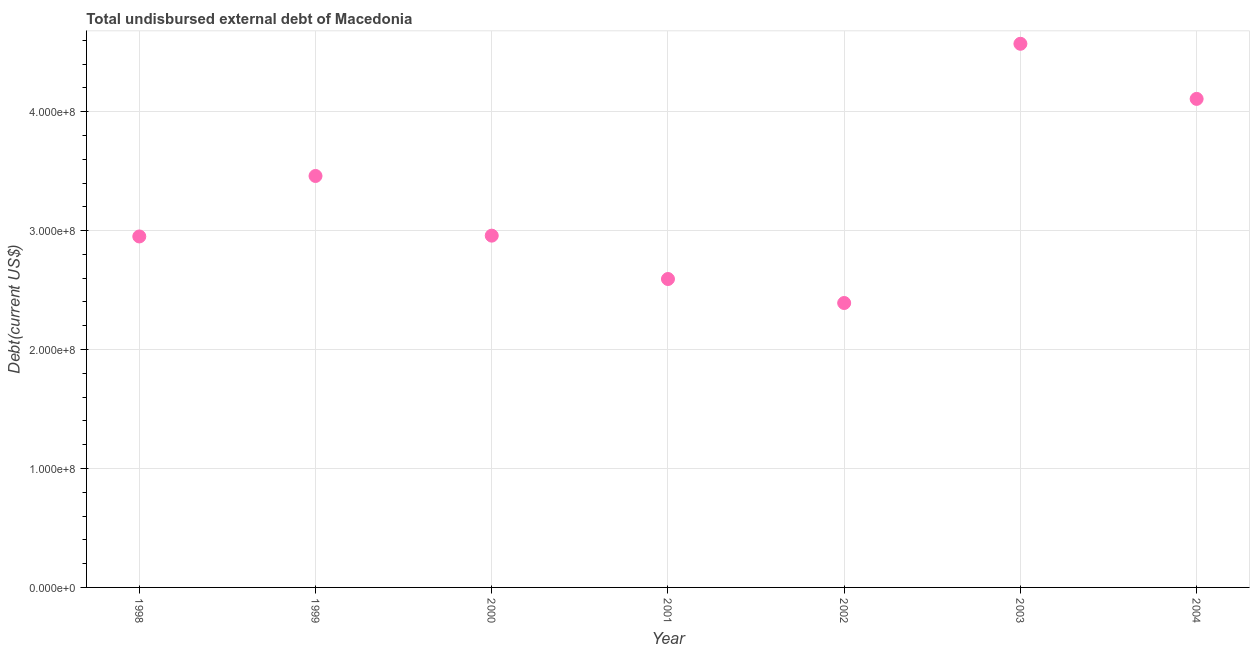What is the total debt in 2003?
Make the answer very short. 4.57e+08. Across all years, what is the maximum total debt?
Your answer should be compact. 4.57e+08. Across all years, what is the minimum total debt?
Give a very brief answer. 2.39e+08. What is the sum of the total debt?
Make the answer very short. 2.30e+09. What is the difference between the total debt in 2000 and 2004?
Make the answer very short. -1.15e+08. What is the average total debt per year?
Make the answer very short. 3.29e+08. What is the median total debt?
Your answer should be compact. 2.96e+08. In how many years, is the total debt greater than 420000000 US$?
Make the answer very short. 1. Do a majority of the years between 1998 and 2001 (inclusive) have total debt greater than 100000000 US$?
Provide a succinct answer. Yes. What is the ratio of the total debt in 2000 to that in 2002?
Keep it short and to the point. 1.24. What is the difference between the highest and the second highest total debt?
Provide a short and direct response. 4.63e+07. Is the sum of the total debt in 1998 and 1999 greater than the maximum total debt across all years?
Make the answer very short. Yes. What is the difference between the highest and the lowest total debt?
Ensure brevity in your answer.  2.18e+08. In how many years, is the total debt greater than the average total debt taken over all years?
Your answer should be compact. 3. Does the total debt monotonically increase over the years?
Keep it short and to the point. No. How many dotlines are there?
Provide a succinct answer. 1. How many years are there in the graph?
Offer a terse response. 7. What is the difference between two consecutive major ticks on the Y-axis?
Your response must be concise. 1.00e+08. Does the graph contain any zero values?
Your answer should be compact. No. What is the title of the graph?
Give a very brief answer. Total undisbursed external debt of Macedonia. What is the label or title of the Y-axis?
Make the answer very short. Debt(current US$). What is the Debt(current US$) in 1998?
Your answer should be very brief. 2.95e+08. What is the Debt(current US$) in 1999?
Your response must be concise. 3.46e+08. What is the Debt(current US$) in 2000?
Make the answer very short. 2.96e+08. What is the Debt(current US$) in 2001?
Your answer should be very brief. 2.59e+08. What is the Debt(current US$) in 2002?
Your answer should be very brief. 2.39e+08. What is the Debt(current US$) in 2003?
Offer a terse response. 4.57e+08. What is the Debt(current US$) in 2004?
Your answer should be very brief. 4.11e+08. What is the difference between the Debt(current US$) in 1998 and 1999?
Provide a short and direct response. -5.08e+07. What is the difference between the Debt(current US$) in 1998 and 2000?
Give a very brief answer. -6.78e+05. What is the difference between the Debt(current US$) in 1998 and 2001?
Provide a succinct answer. 3.58e+07. What is the difference between the Debt(current US$) in 1998 and 2002?
Offer a very short reply. 5.59e+07. What is the difference between the Debt(current US$) in 1998 and 2003?
Keep it short and to the point. -1.62e+08. What is the difference between the Debt(current US$) in 1998 and 2004?
Make the answer very short. -1.16e+08. What is the difference between the Debt(current US$) in 1999 and 2000?
Your answer should be very brief. 5.02e+07. What is the difference between the Debt(current US$) in 1999 and 2001?
Provide a short and direct response. 8.66e+07. What is the difference between the Debt(current US$) in 1999 and 2002?
Offer a very short reply. 1.07e+08. What is the difference between the Debt(current US$) in 1999 and 2003?
Your answer should be compact. -1.11e+08. What is the difference between the Debt(current US$) in 1999 and 2004?
Provide a short and direct response. -6.48e+07. What is the difference between the Debt(current US$) in 2000 and 2001?
Give a very brief answer. 3.65e+07. What is the difference between the Debt(current US$) in 2000 and 2002?
Provide a succinct answer. 5.66e+07. What is the difference between the Debt(current US$) in 2000 and 2003?
Ensure brevity in your answer.  -1.61e+08. What is the difference between the Debt(current US$) in 2000 and 2004?
Make the answer very short. -1.15e+08. What is the difference between the Debt(current US$) in 2001 and 2002?
Make the answer very short. 2.02e+07. What is the difference between the Debt(current US$) in 2001 and 2003?
Provide a succinct answer. -1.98e+08. What is the difference between the Debt(current US$) in 2001 and 2004?
Ensure brevity in your answer.  -1.51e+08. What is the difference between the Debt(current US$) in 2002 and 2003?
Ensure brevity in your answer.  -2.18e+08. What is the difference between the Debt(current US$) in 2002 and 2004?
Keep it short and to the point. -1.72e+08. What is the difference between the Debt(current US$) in 2003 and 2004?
Your answer should be compact. 4.63e+07. What is the ratio of the Debt(current US$) in 1998 to that in 1999?
Give a very brief answer. 0.85. What is the ratio of the Debt(current US$) in 1998 to that in 2000?
Your response must be concise. 1. What is the ratio of the Debt(current US$) in 1998 to that in 2001?
Make the answer very short. 1.14. What is the ratio of the Debt(current US$) in 1998 to that in 2002?
Your response must be concise. 1.23. What is the ratio of the Debt(current US$) in 1998 to that in 2003?
Make the answer very short. 0.65. What is the ratio of the Debt(current US$) in 1998 to that in 2004?
Offer a terse response. 0.72. What is the ratio of the Debt(current US$) in 1999 to that in 2000?
Your answer should be compact. 1.17. What is the ratio of the Debt(current US$) in 1999 to that in 2001?
Your response must be concise. 1.33. What is the ratio of the Debt(current US$) in 1999 to that in 2002?
Provide a succinct answer. 1.45. What is the ratio of the Debt(current US$) in 1999 to that in 2003?
Make the answer very short. 0.76. What is the ratio of the Debt(current US$) in 1999 to that in 2004?
Provide a short and direct response. 0.84. What is the ratio of the Debt(current US$) in 2000 to that in 2001?
Offer a very short reply. 1.14. What is the ratio of the Debt(current US$) in 2000 to that in 2002?
Provide a succinct answer. 1.24. What is the ratio of the Debt(current US$) in 2000 to that in 2003?
Provide a succinct answer. 0.65. What is the ratio of the Debt(current US$) in 2000 to that in 2004?
Offer a very short reply. 0.72. What is the ratio of the Debt(current US$) in 2001 to that in 2002?
Offer a terse response. 1.08. What is the ratio of the Debt(current US$) in 2001 to that in 2003?
Ensure brevity in your answer.  0.57. What is the ratio of the Debt(current US$) in 2001 to that in 2004?
Ensure brevity in your answer.  0.63. What is the ratio of the Debt(current US$) in 2002 to that in 2003?
Provide a short and direct response. 0.52. What is the ratio of the Debt(current US$) in 2002 to that in 2004?
Provide a succinct answer. 0.58. What is the ratio of the Debt(current US$) in 2003 to that in 2004?
Give a very brief answer. 1.11. 